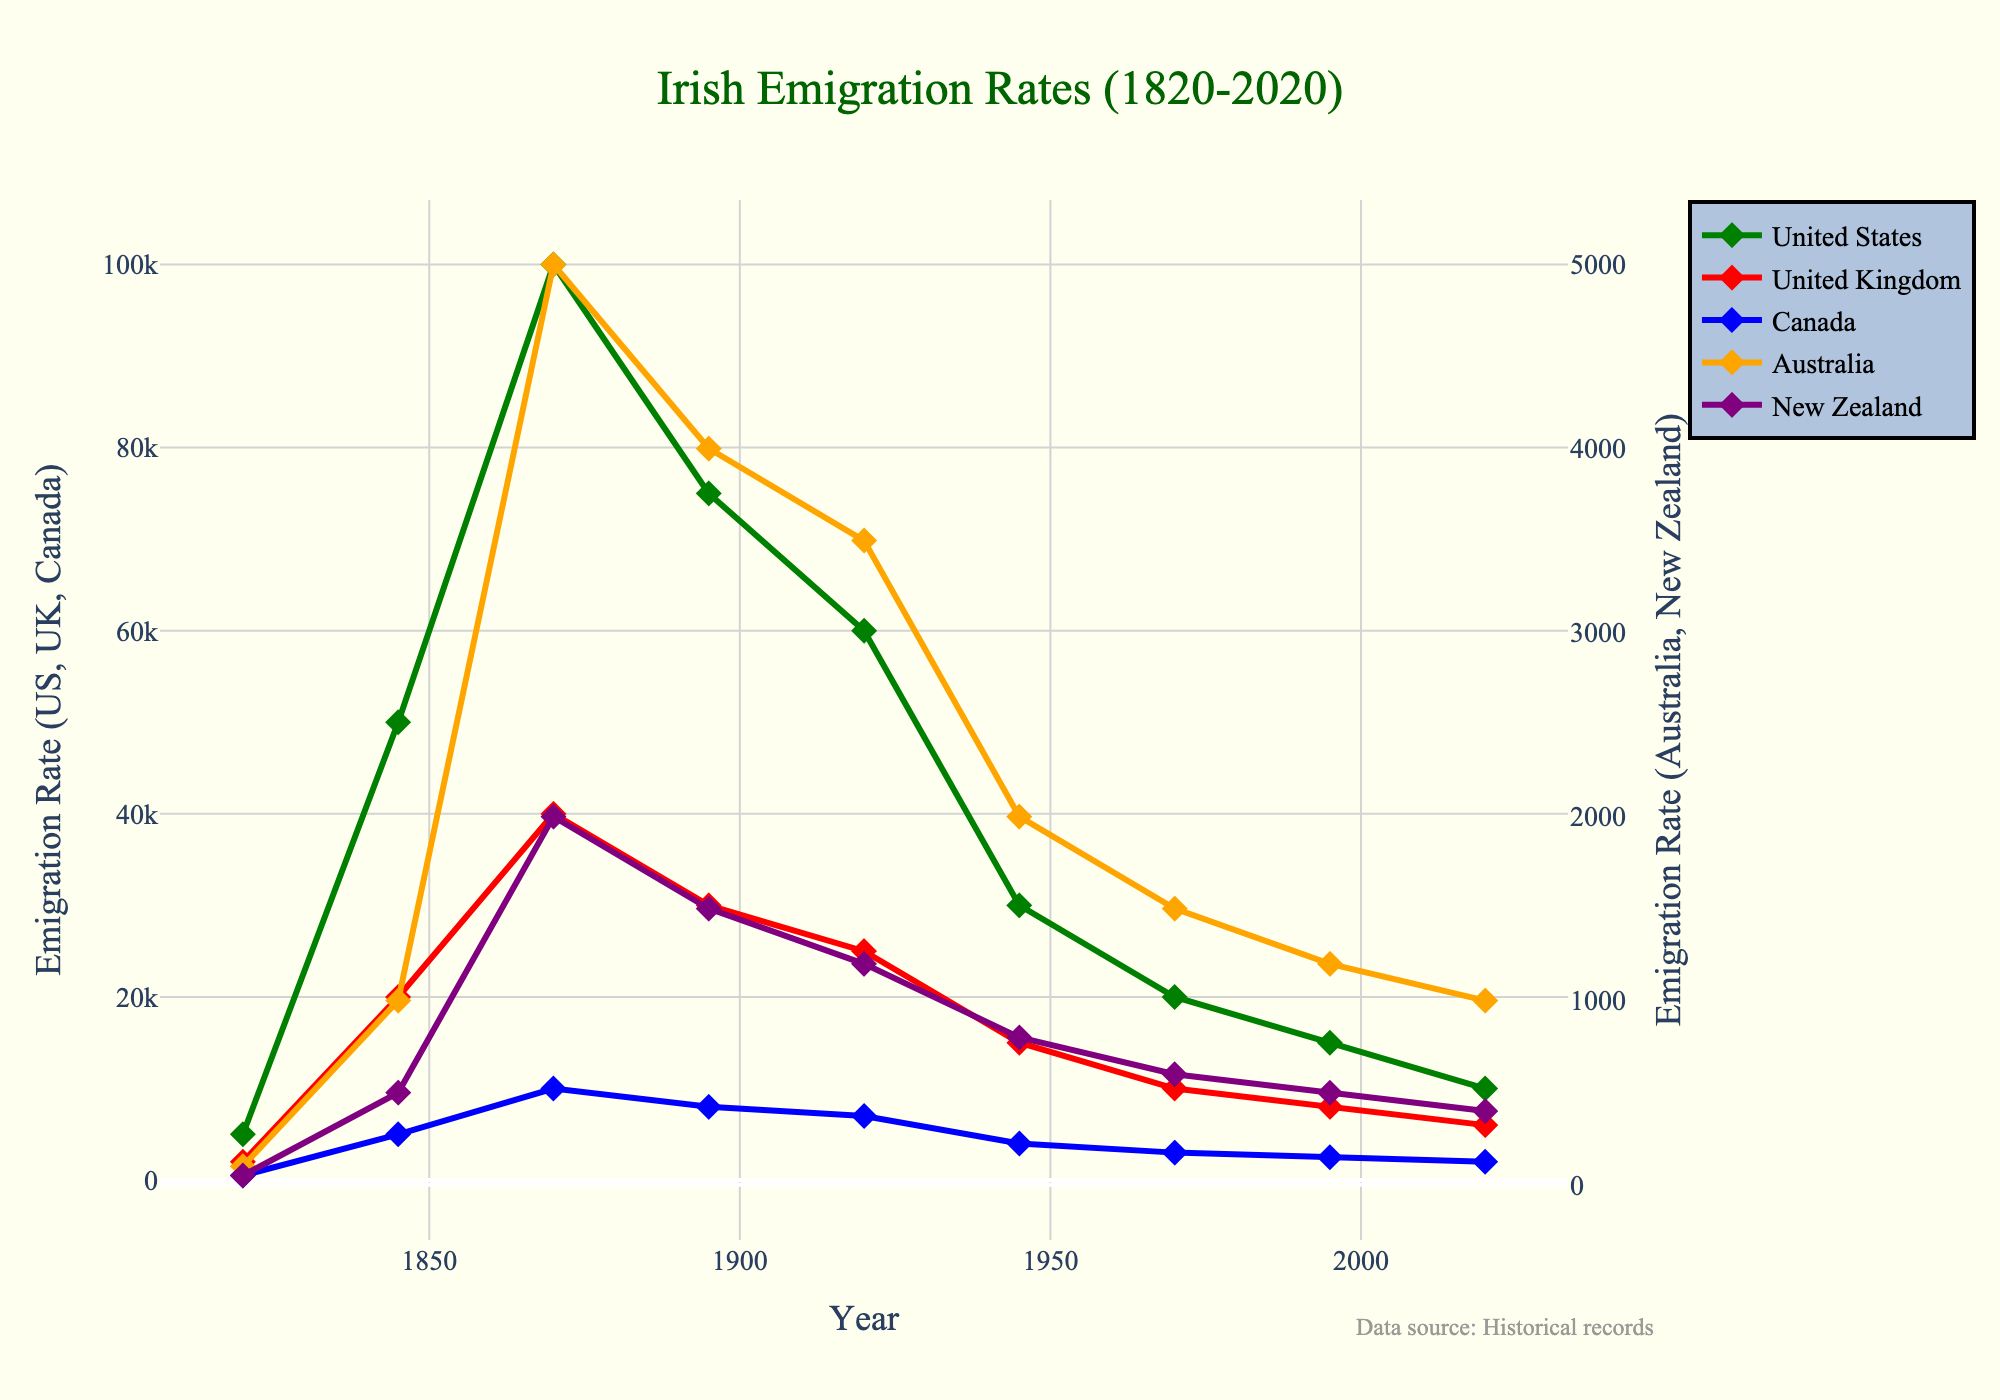How did the emigration rate to the United States change from 1845 to 1870? To determine this, look at the y-values corresponding to the United States for both 1845 and 1870. The emigration rate increased from 50,000 in 1845 to 100,000 in 1870.
Answer: It doubled Which country had the highest emigration rate from Ireland in 1920? By comparing the y-values for all countries in 1920, we find that the United States had the highest emigration rate with 60,000.
Answer: United States What was the total emigration rate to the United States and the United Kingdom in 1845? Sum the emigration rates for both countries in 1845: 50,000 (United States) + 20,000 (United Kingdom) = 70,000.
Answer: 70,000 Which two countries had a decline in emigration rates from 1920 to 1945? Observe the trend lines from 1920 to 1945. Both the United States (60,000 to 30,000) and the United Kingdom (25,000 to 15,000) experienced declines.
Answer: United States and United Kingdom In which year did New Zealand have the highest emigration rate, and what was it? Look for the peak point in the New Zealand line. The highest rate was in 1870 with 2,000 emigrations.
Answer: 1870, 2,000 How does the emigration rate to Australia in 1845 compare to 2020? Compare the y-values for Australia in 1845 and 2020. The rate increased from 1,000 in 1845 to 1,000 in 2020.
Answer: Equal What's the average emigration rate to Canada over all the years provided? Sum the emigration rates for Canada across all years (500 + 5,000 + 10,000 + 8,000 + 7,000 + 4,000 + 3,000 + 2,500 + 2,000 = 42,000), then divide by the number of years (9): 42,000 / 9 ≈ 4,667.
Answer: Approximately 4,667 Between which consecutive years did the emigration rate to the United States decrease the most? By calculating the differences, the largest decrease is between 1870 (100,000) and 1895 (75,000), which is 100,000 - 75,000 = 25,000.
Answer: 1870 to 1895 What's the total emigration rate to Australia and New Zealand in 1870? Sum the emigration rates for both countries in 1870: 5,000 (Australia) + 2,000 (New Zealand) = 7,000.
Answer: 7,000 Which country has the least variation in emigration rates across all years? To determine the least variation, observe the line with the smallest changes in y-values over the years. New Zealand's line has the least variation.
Answer: New Zealand 